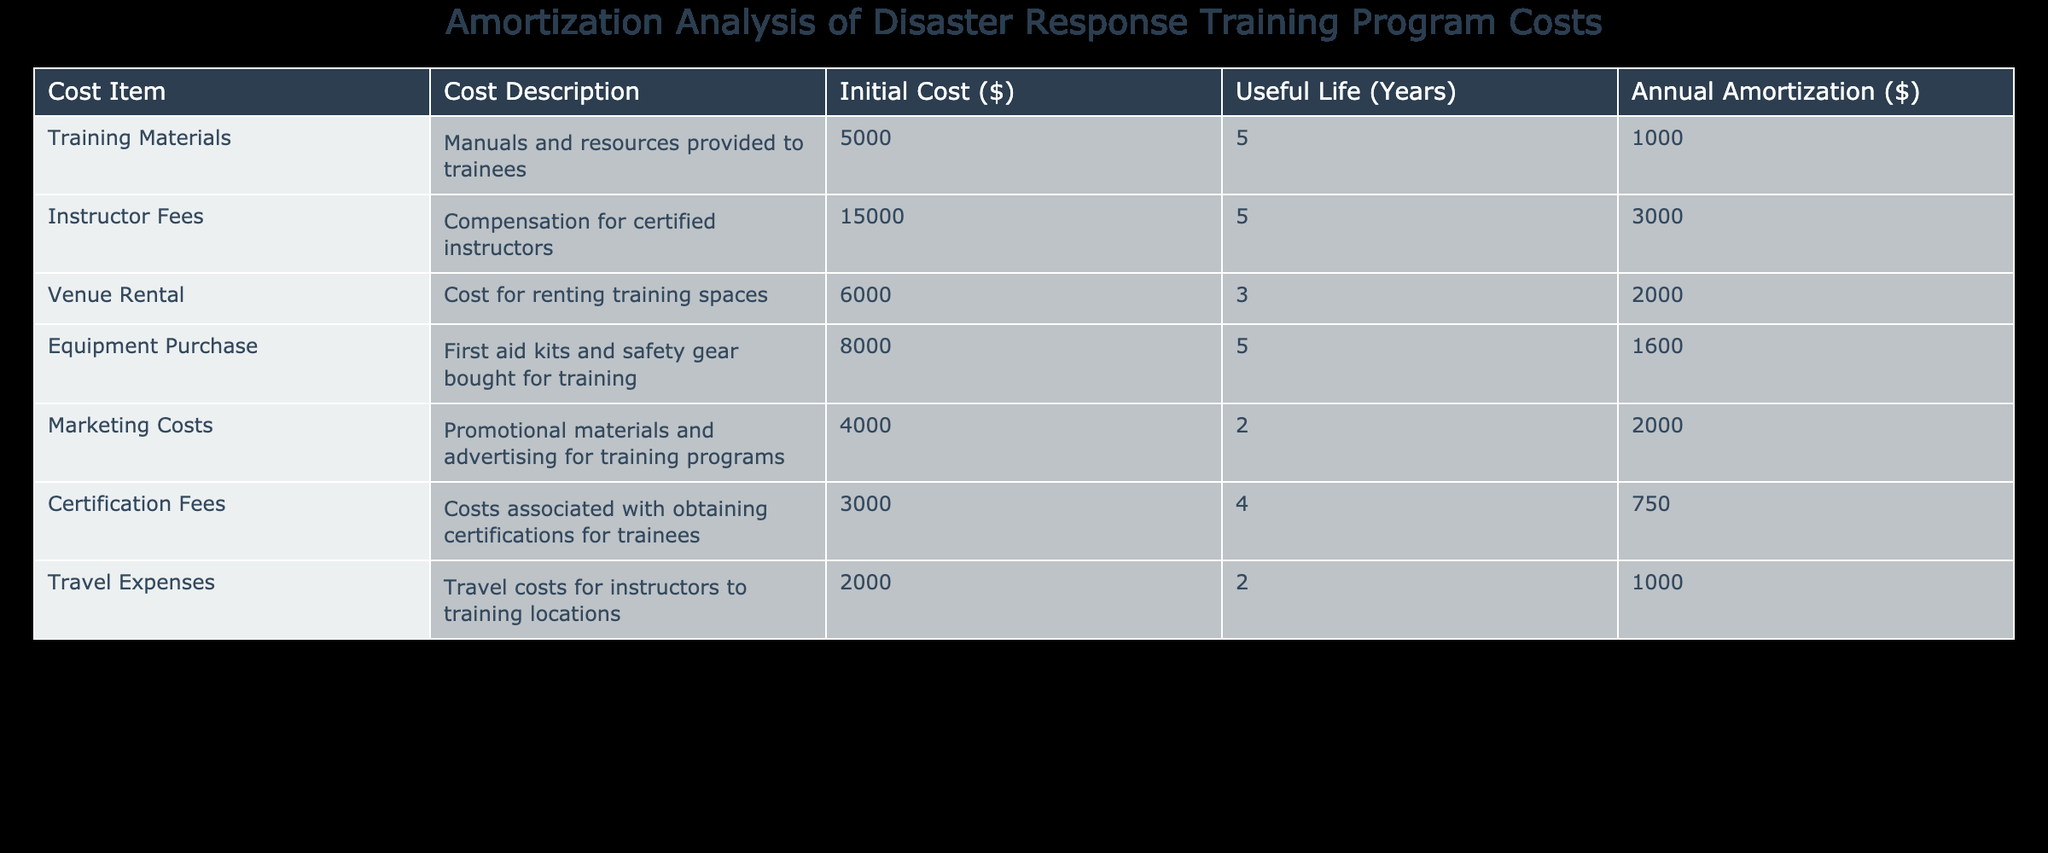What is the total initial cost of all training materials listed in the table? To find the total initial cost of all training materials, I will add the Initial Cost for each item: 5000 + 15000 + 6000 + 8000 + 4000 + 3000 + 2000. The sum comes to 5000 + 15000 + 6000 + 8000 + 4000 + 3000 + 2000 = 50000.
Answer: 50000 What is the useful life of the venue rental? The useful life of the venue rental is listed directly in the table under the Useful Life column for that cost item. It shows as 3 years.
Answer: 3 years How much is spent annually on instructor fees? The annual amortization for instructor fees is provided in the table under the Annual Amortization column. It indicates a cost of 3000 annually.
Answer: 3000 Which cost item has the longest useful life and what is that duration? To determine which cost item has the longest useful life, I will compare the Useful Life values: The longest duration is 5 years, attributed to Training Materials, Equipment Purchase, and Instructor Fees.
Answer: 5 years Is the certification fee for obtaining certifications greater than 1000? The certification fee is listed under the Initial Cost column. It shows as 3000, which is greater than 1000.
Answer: Yes What is the average annual amortization across all cost items? To find the average annual amortization, I will sum the Annual Amortization values: (1000 + 3000 + 2000 + 1600 + 2000 + 750 + 1000 = 11350) and then divide by the total number of cost items (7). Thus, the average is 11350 / 7 = 1614.29.
Answer: 1614.29 How much do marketing costs contribute to the total initial expense of the training program? The marketing costs are listed with an initial cost of 4000. To assess its contribution, I will derive its proportion from the total initial cost. Total initial cost is 50000, thus its contribution is (4000 / 50000) * 100 = 8%.
Answer: 8% Does the total cost of travel expenses exceed the total cost of equipment purchase? The travel expenses amount to 2000 and the equipment purchase is 8000. Comparing these two, 2000 is less than 8000, so no, travel expenses do not exceed equipment purchase.
Answer: No What is the total amortization cost for items with a useful life of 2 years? I will only sum the Annual Amortization for the items that have a useful life of 2 years, which are Marketing Costs and Travel Expenses (2000 + 1000 = 3000).
Answer: 3000 